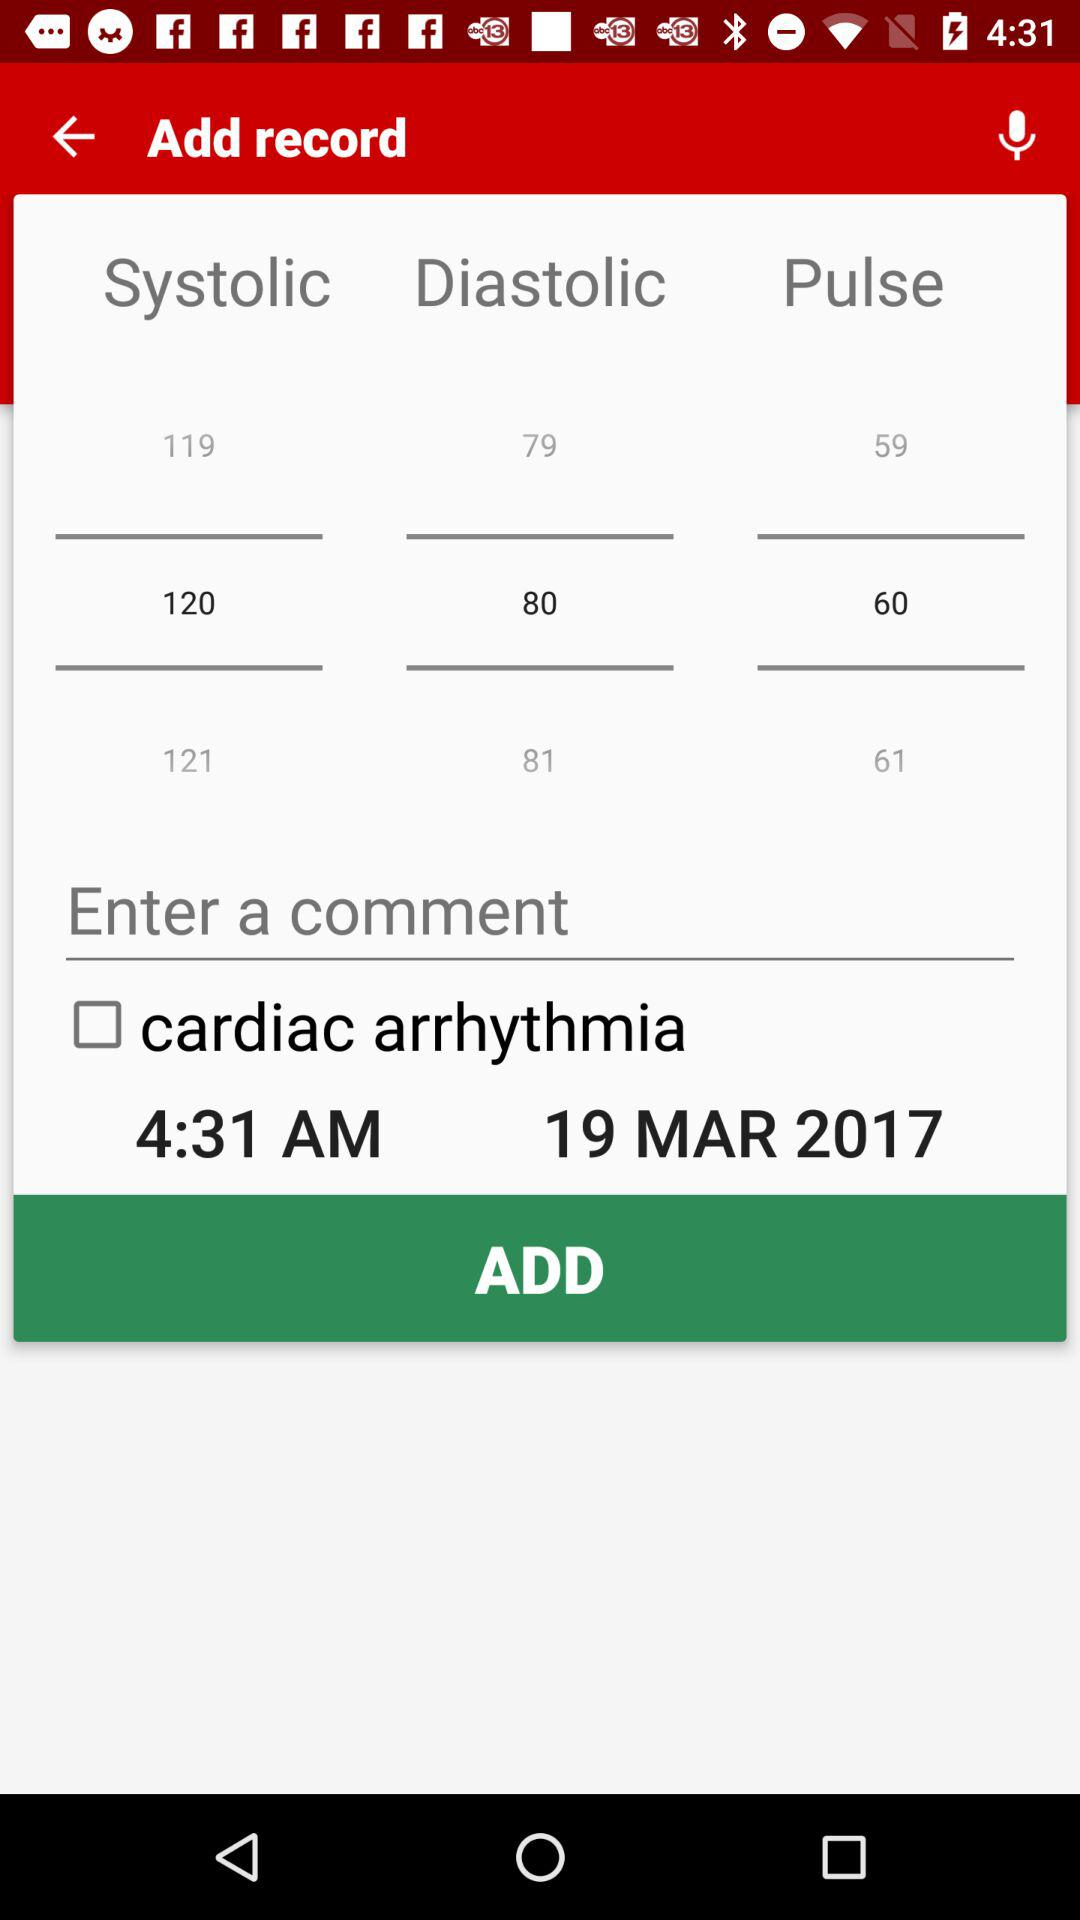What is the pulse rate? The pulse rate is 60. 